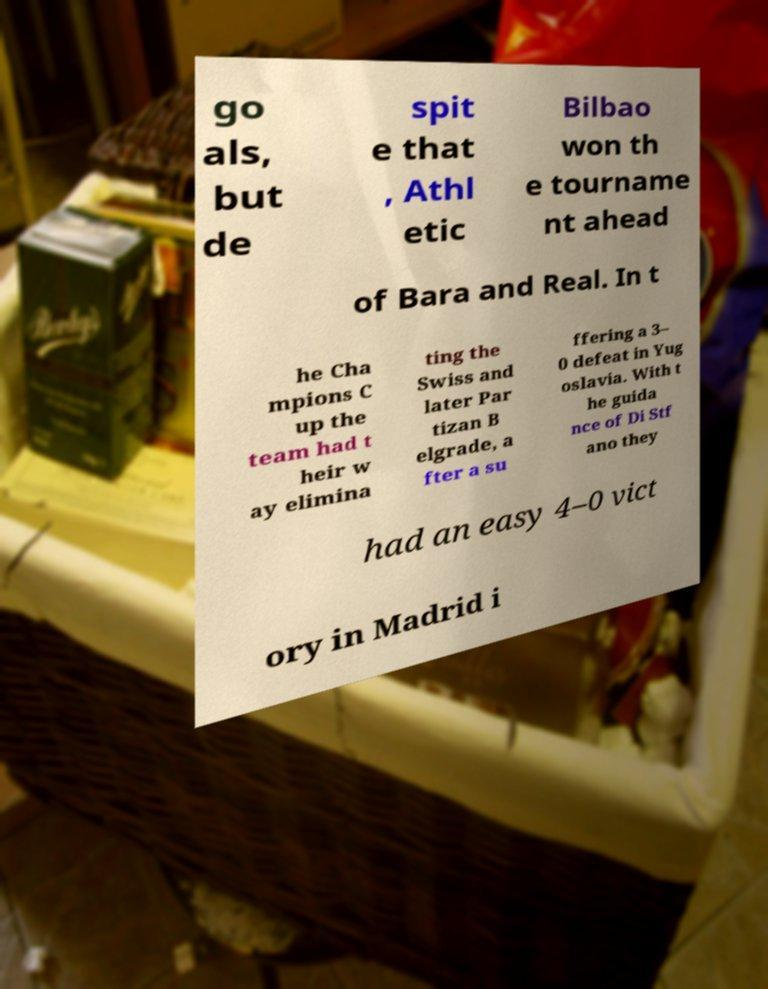Could you extract and type out the text from this image? go als, but de spit e that , Athl etic Bilbao won th e tourname nt ahead of Bara and Real. In t he Cha mpions C up the team had t heir w ay elimina ting the Swiss and later Par tizan B elgrade, a fter a su ffering a 3– 0 defeat in Yug oslavia. With t he guida nce of Di Stf ano they had an easy 4–0 vict ory in Madrid i 